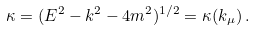Convert formula to latex. <formula><loc_0><loc_0><loc_500><loc_500>\kappa = ( E ^ { 2 } - { k } ^ { 2 } - 4 m ^ { 2 } ) ^ { 1 / 2 } = \kappa ( k _ { \mu } ) \, .</formula> 